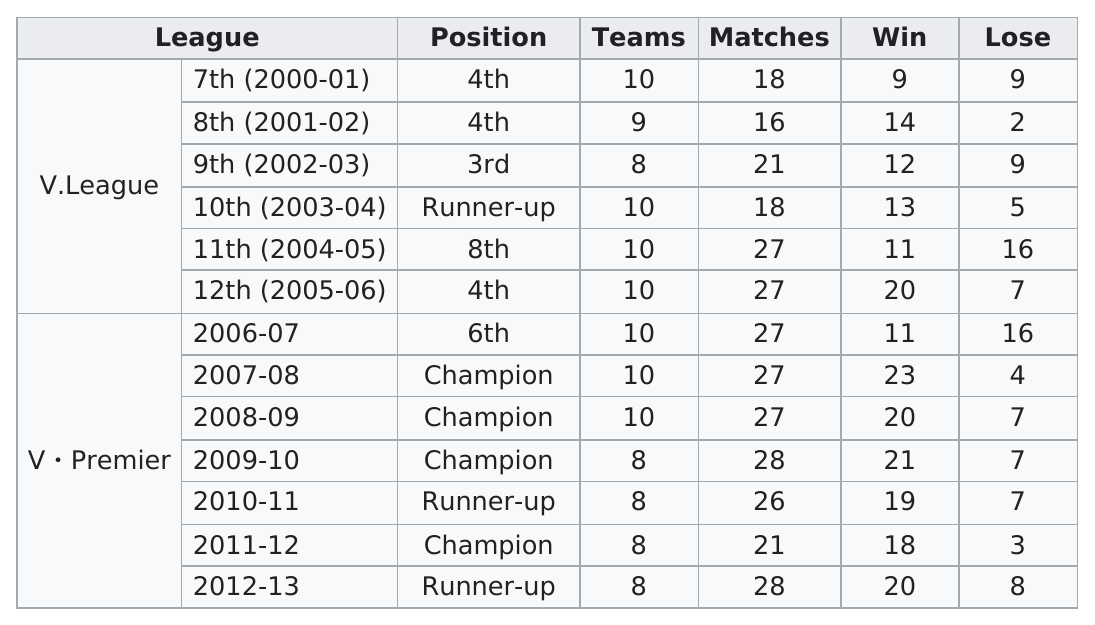Indicate a few pertinent items in this graphic. The team won at most 3 consecutive championships. The Premier League and the Football League have had 10 teams participating consecutively for 6 times. In the year 2007-2008, the number of wins was the highest. They competed in the V Premier for 7 years. During the first year of the Premier League, a total of 27 matches took place. 